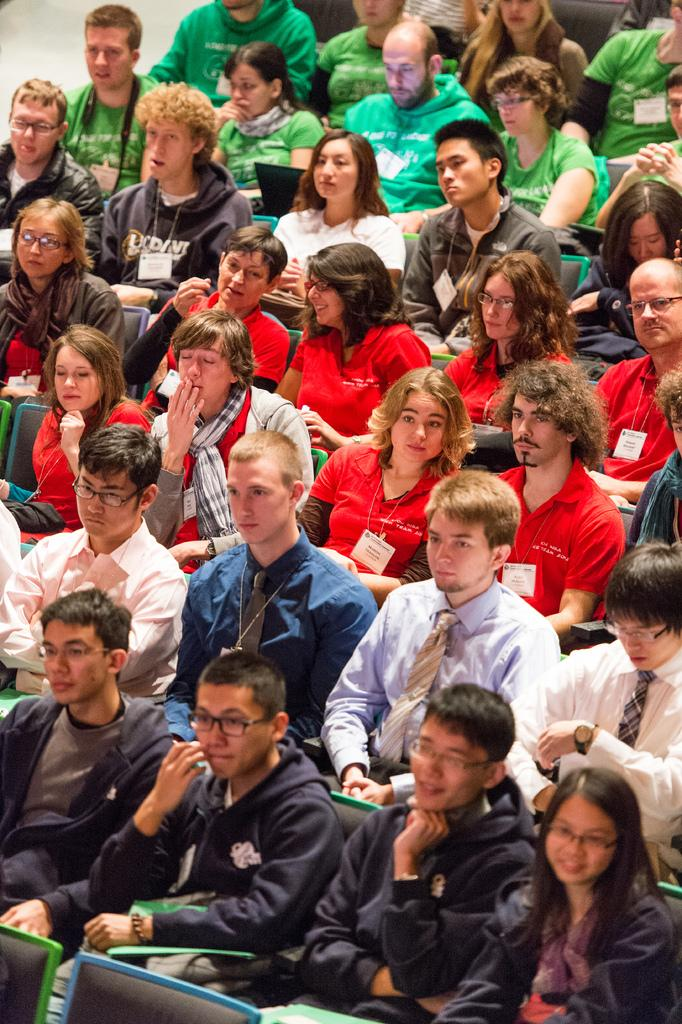Where was the image taken? The image is taken indoors. What are the people in the image doing? There are people sitting on chairs in the image. What objects are some people holding in their hands? Some people are holding laptops and some are holding files in their hands. What type of cabbage is being used as a pillow by the person in the image? There is no cabbage present in the image, and no one is using a cabbage as a pillow. Can you tell me how many kitties are sitting on the laps of the people in the image? There are no kitties present in the image; the people are holding laptops and files, not kitties. 